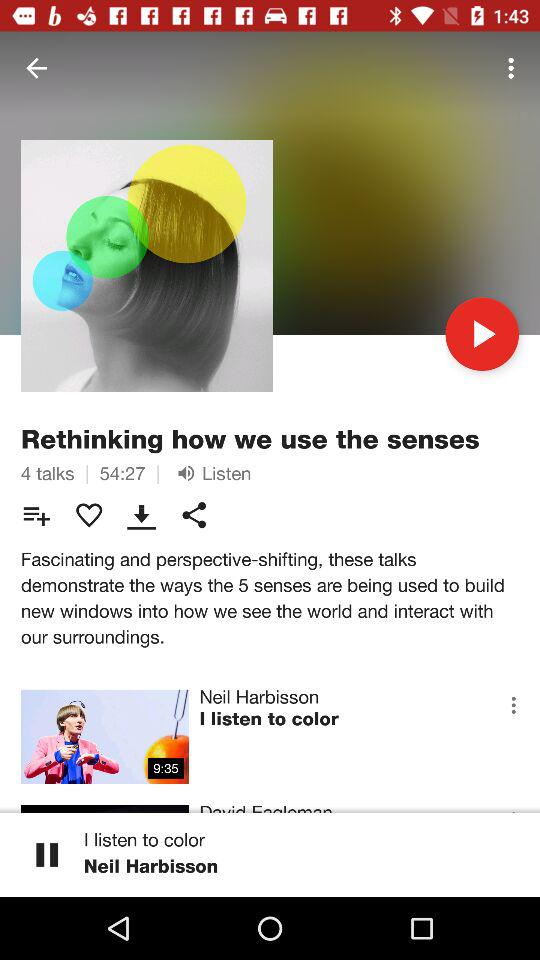What is the duration of the current TED Talk playing? The duration is 9 minutes and 35 seconds. 